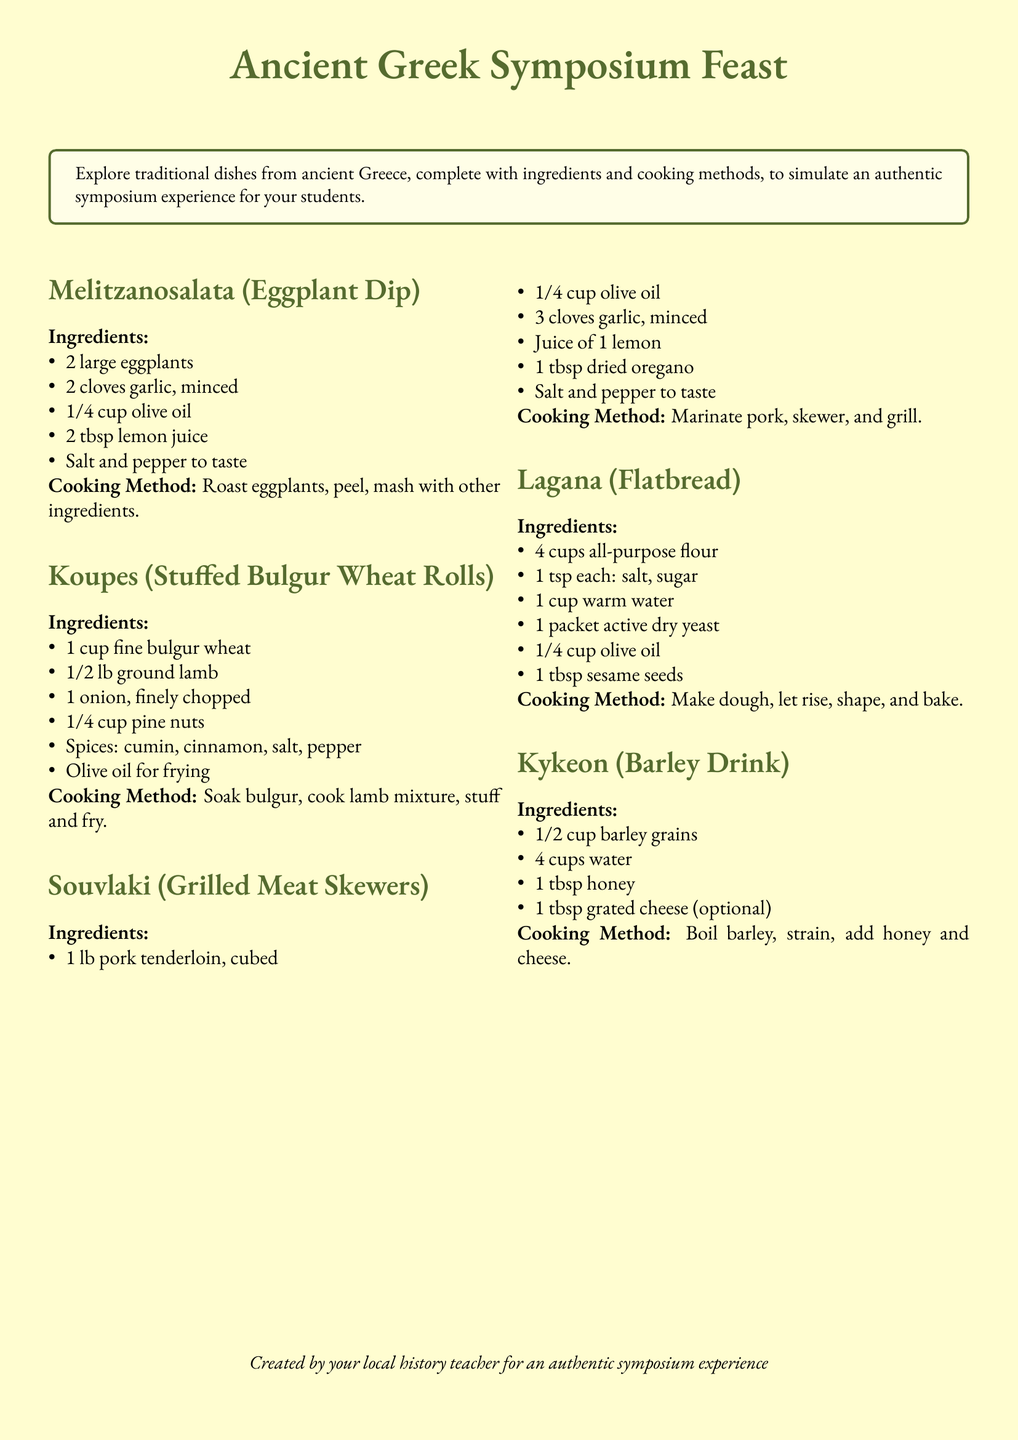What is the main title of the document? The title is prominently displayed at the top of the document, indicating the focus of the content.
Answer: Ancient Greek Symposium Feast How many dishes are listed in the document? Each dish is presented as a separate section, and by counting these sections, the total number can be determined.
Answer: 5 What ingredient is common in Melitzanosalata and Souvlaki? The ingredients are listed for each dish, and both recipes can be compared to find common items.
Answer: Olive oil What is the main ingredient in Kykeon? The ingredients are clearly listed, and the primary component can be identified.
Answer: Barley grains What cooking method is used for Koupes? The cooking method is specifically described for each dish, providing insights into the preparation process.
Answer: Stuff and fry Which dish contains ground lamb? Analyzing the list of ingredients in each dish helps pinpoint this specific meat in one of the recipes.
Answer: Koupes What is added to Kykeon for sweetness? Among the ingredients for this drink, a particular item is noted for its sweetening properties.
Answer: Honey How long is the dough for Lagana allowed to rise? The document does not specify an exact time, requiring deeper understanding or reasoning based on typical bread-making practices in ancient Greek culture.
Answer: Not stated 